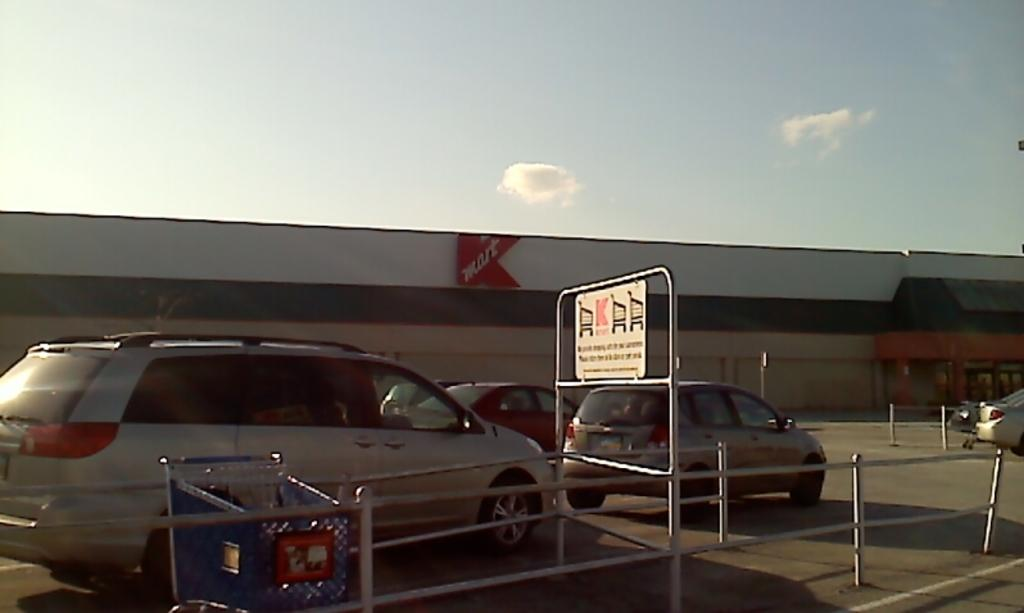What can be seen moving on the road in the image? There are vehicles on the road in the image. What is attached to a pole in the image? There is a white color board attached to a pole in the image. What can be seen in the background of the image? The sky is visible in the background of the image, with white and blue colors. What is the position of the nation in the image? There is no nation present in the image; it only shows vehicles on the road, a white color board, and the sky. Is there a stream visible in the image? There is no stream present in the image; it only shows vehicles on the road, a white color board, and the sky. 